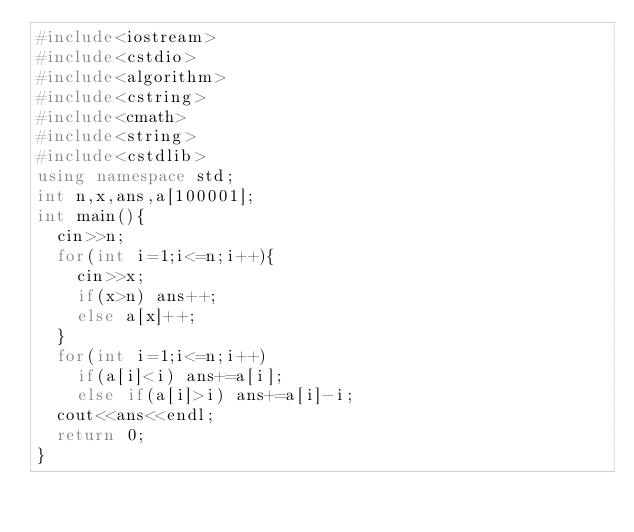<code> <loc_0><loc_0><loc_500><loc_500><_C++_>#include<iostream>
#include<cstdio>
#include<algorithm>
#include<cstring>
#include<cmath>
#include<string>
#include<cstdlib>
using namespace std;
int n,x,ans,a[100001];
int main(){
	cin>>n;
	for(int i=1;i<=n;i++){
		cin>>x;
		if(x>n) ans++;
		else a[x]++;
	}
	for(int i=1;i<=n;i++)
		if(a[i]<i) ans+=a[i];
		else if(a[i]>i) ans+=a[i]-i;
	cout<<ans<<endl;
 	return 0;
}</code> 